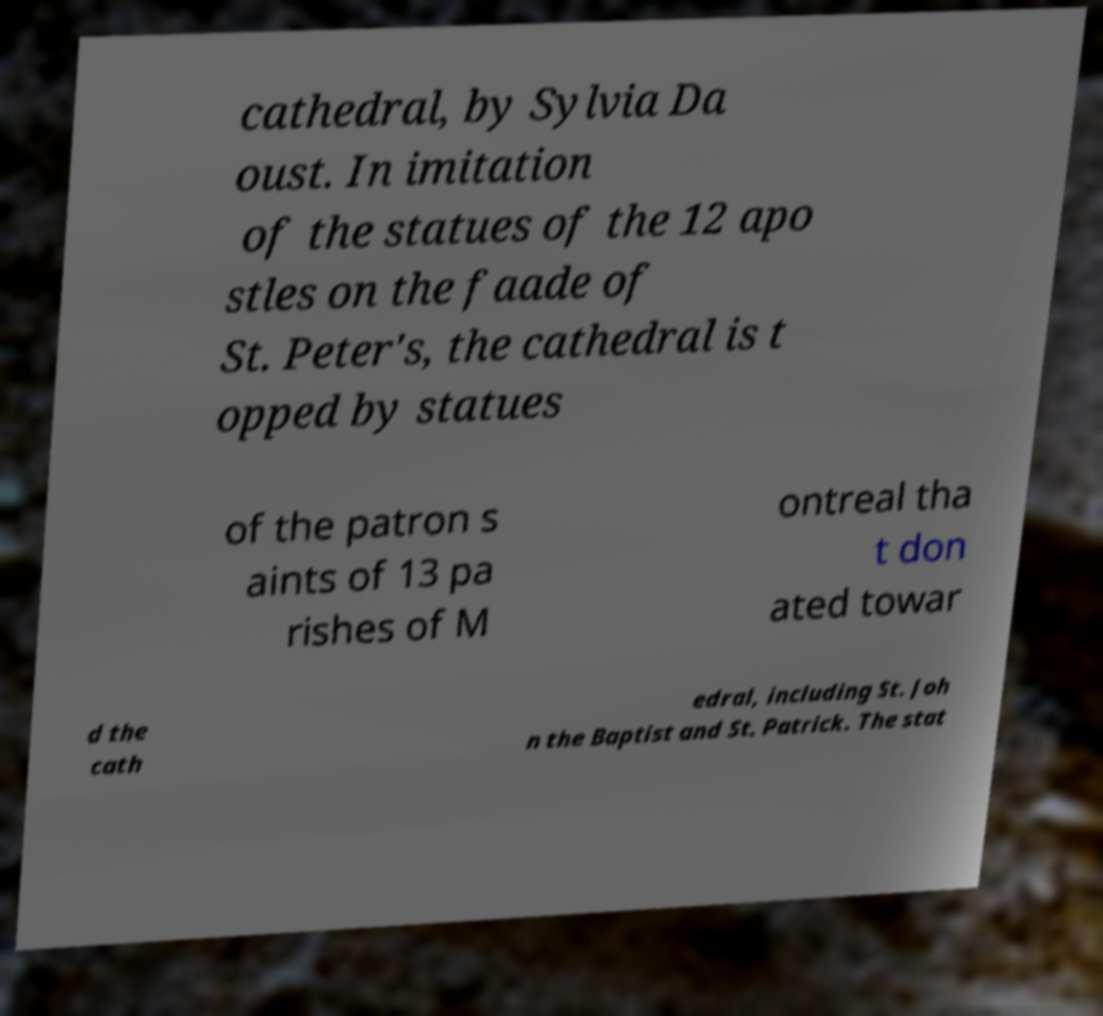I need the written content from this picture converted into text. Can you do that? cathedral, by Sylvia Da oust. In imitation of the statues of the 12 apo stles on the faade of St. Peter's, the cathedral is t opped by statues of the patron s aints of 13 pa rishes of M ontreal tha t don ated towar d the cath edral, including St. Joh n the Baptist and St. Patrick. The stat 